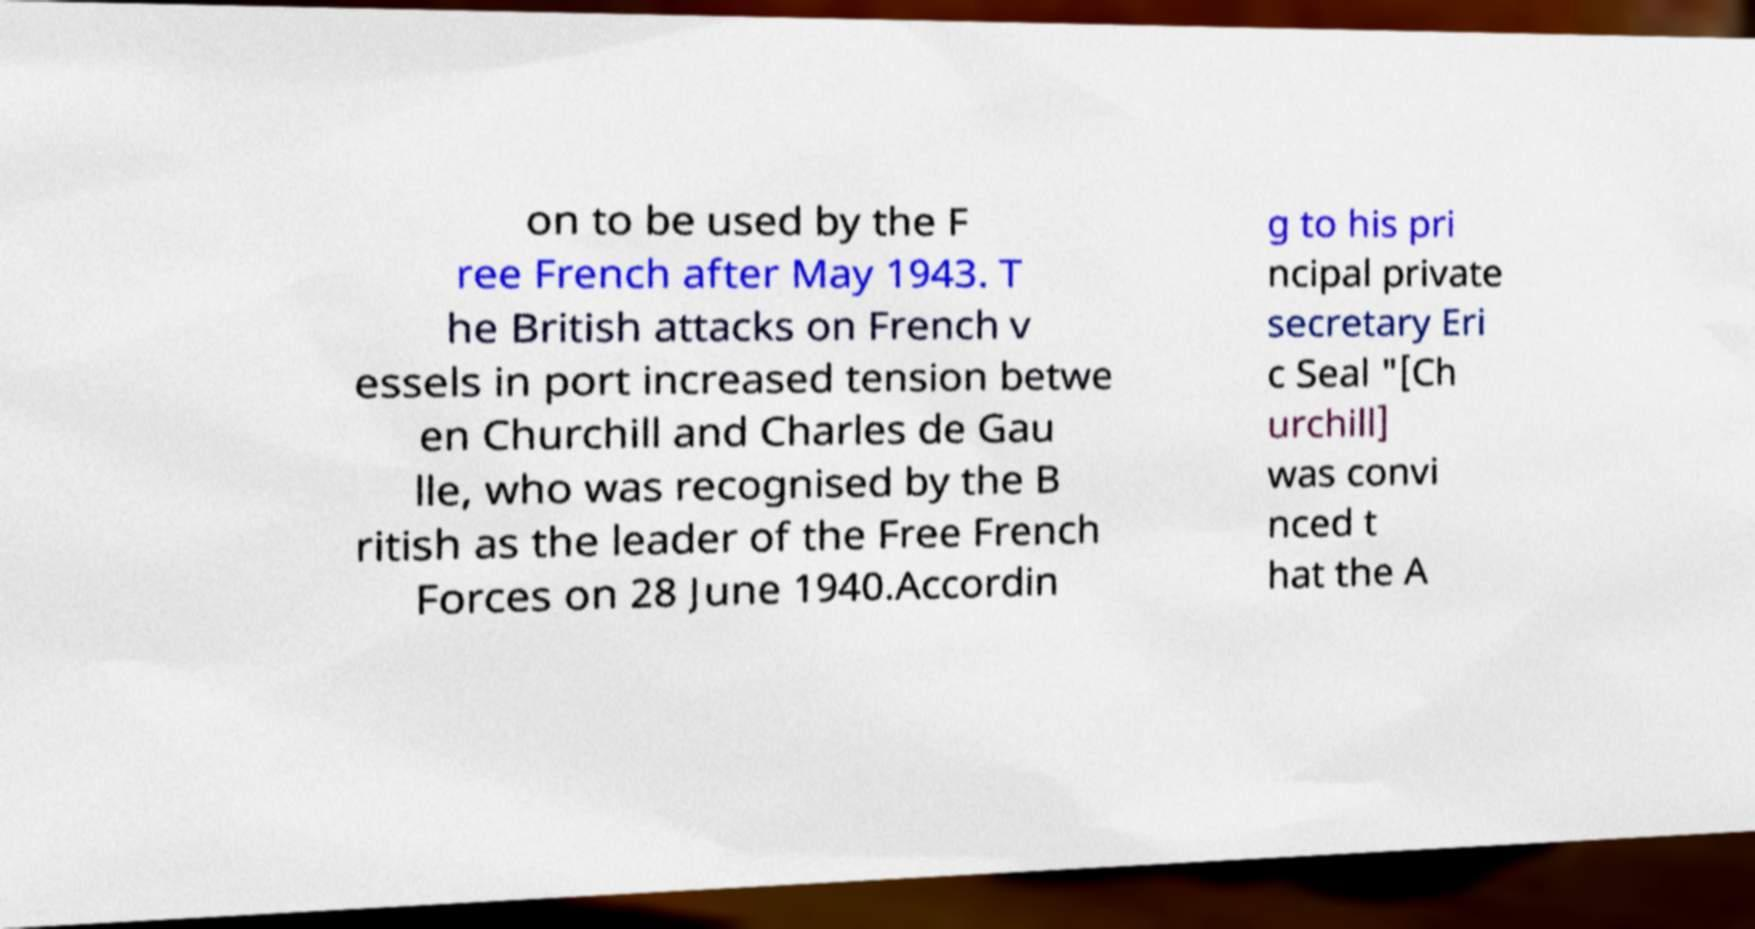There's text embedded in this image that I need extracted. Can you transcribe it verbatim? on to be used by the F ree French after May 1943. T he British attacks on French v essels in port increased tension betwe en Churchill and Charles de Gau lle, who was recognised by the B ritish as the leader of the Free French Forces on 28 June 1940.Accordin g to his pri ncipal private secretary Eri c Seal "[Ch urchill] was convi nced t hat the A 